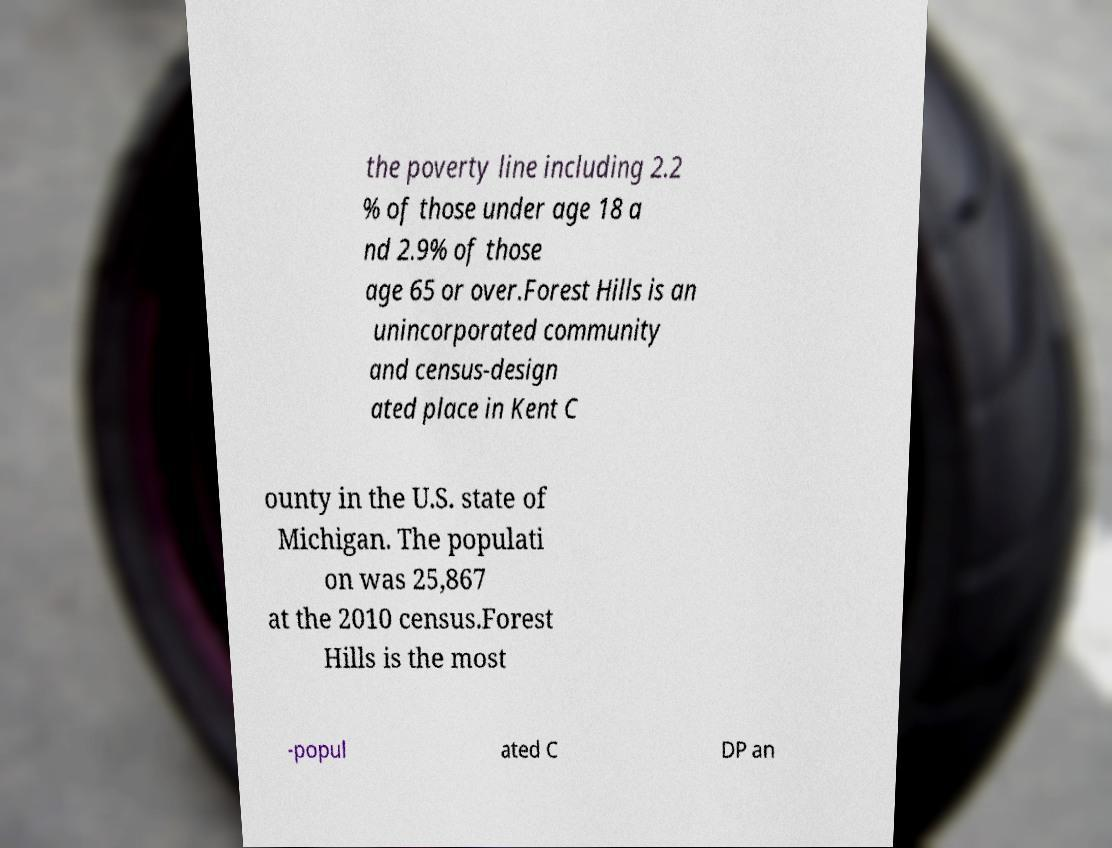I need the written content from this picture converted into text. Can you do that? the poverty line including 2.2 % of those under age 18 a nd 2.9% of those age 65 or over.Forest Hills is an unincorporated community and census-design ated place in Kent C ounty in the U.S. state of Michigan. The populati on was 25,867 at the 2010 census.Forest Hills is the most -popul ated C DP an 